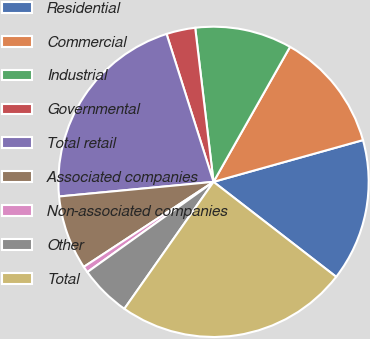Convert chart. <chart><loc_0><loc_0><loc_500><loc_500><pie_chart><fcel>Residential<fcel>Commercial<fcel>Industrial<fcel>Governmental<fcel>Total retail<fcel>Associated companies<fcel>Non-associated companies<fcel>Other<fcel>Total<nl><fcel>14.82%<fcel>12.46%<fcel>10.09%<fcel>3.01%<fcel>21.61%<fcel>7.73%<fcel>0.65%<fcel>5.37%<fcel>24.26%<nl></chart> 